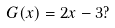Convert formula to latex. <formula><loc_0><loc_0><loc_500><loc_500>G ( x ) = 2 x - 3 ?</formula> 